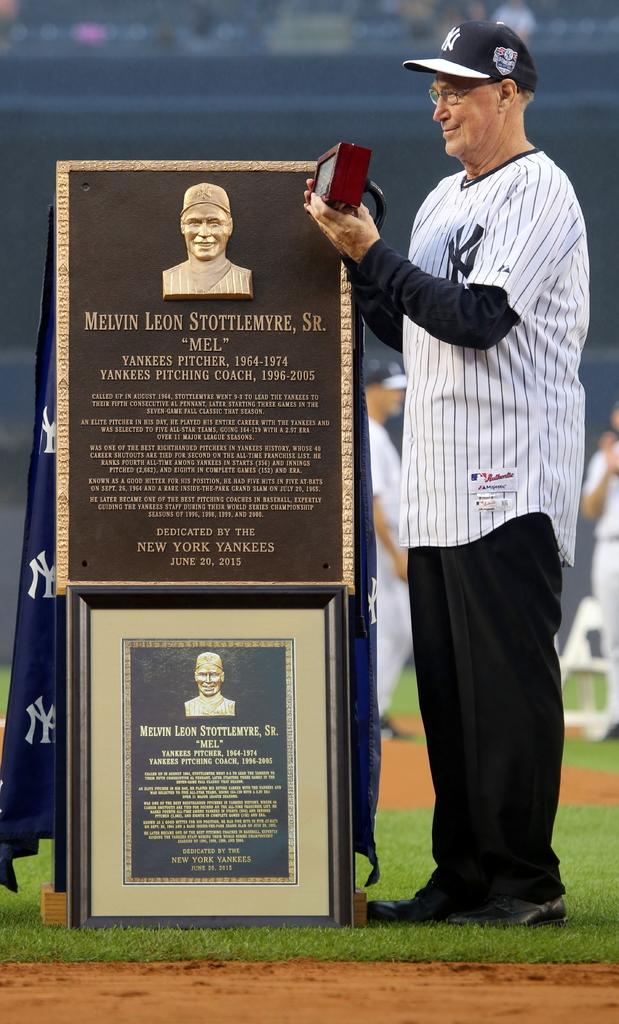<image>
Write a terse but informative summary of the picture. Two commemorative plaques honor the baseball player Melvin Leon Stottlemyre, Sr. 